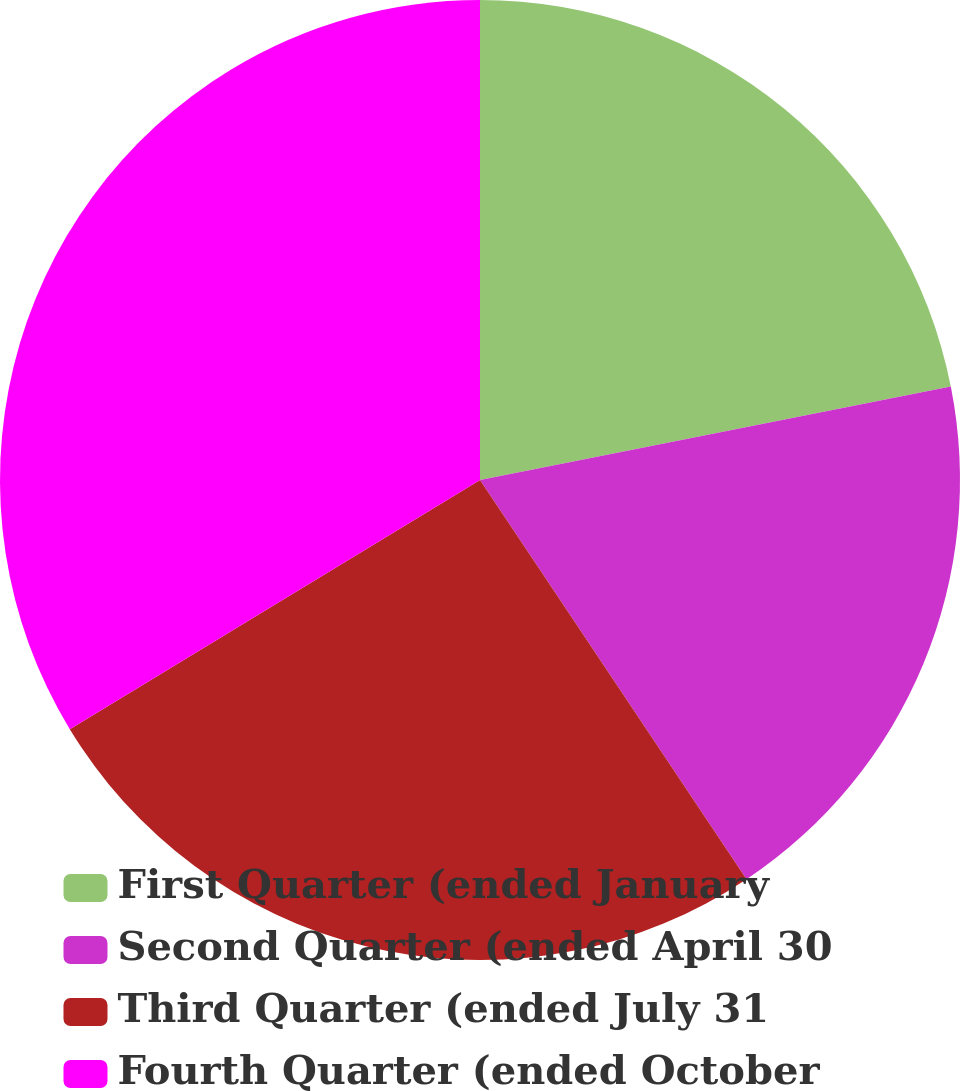Convert chart to OTSL. <chart><loc_0><loc_0><loc_500><loc_500><pie_chart><fcel>First Quarter (ended January<fcel>Second Quarter (ended April 30<fcel>Third Quarter (ended July 31<fcel>Fourth Quarter (ended October<nl><fcel>21.88%<fcel>18.75%<fcel>25.68%<fcel>33.69%<nl></chart> 